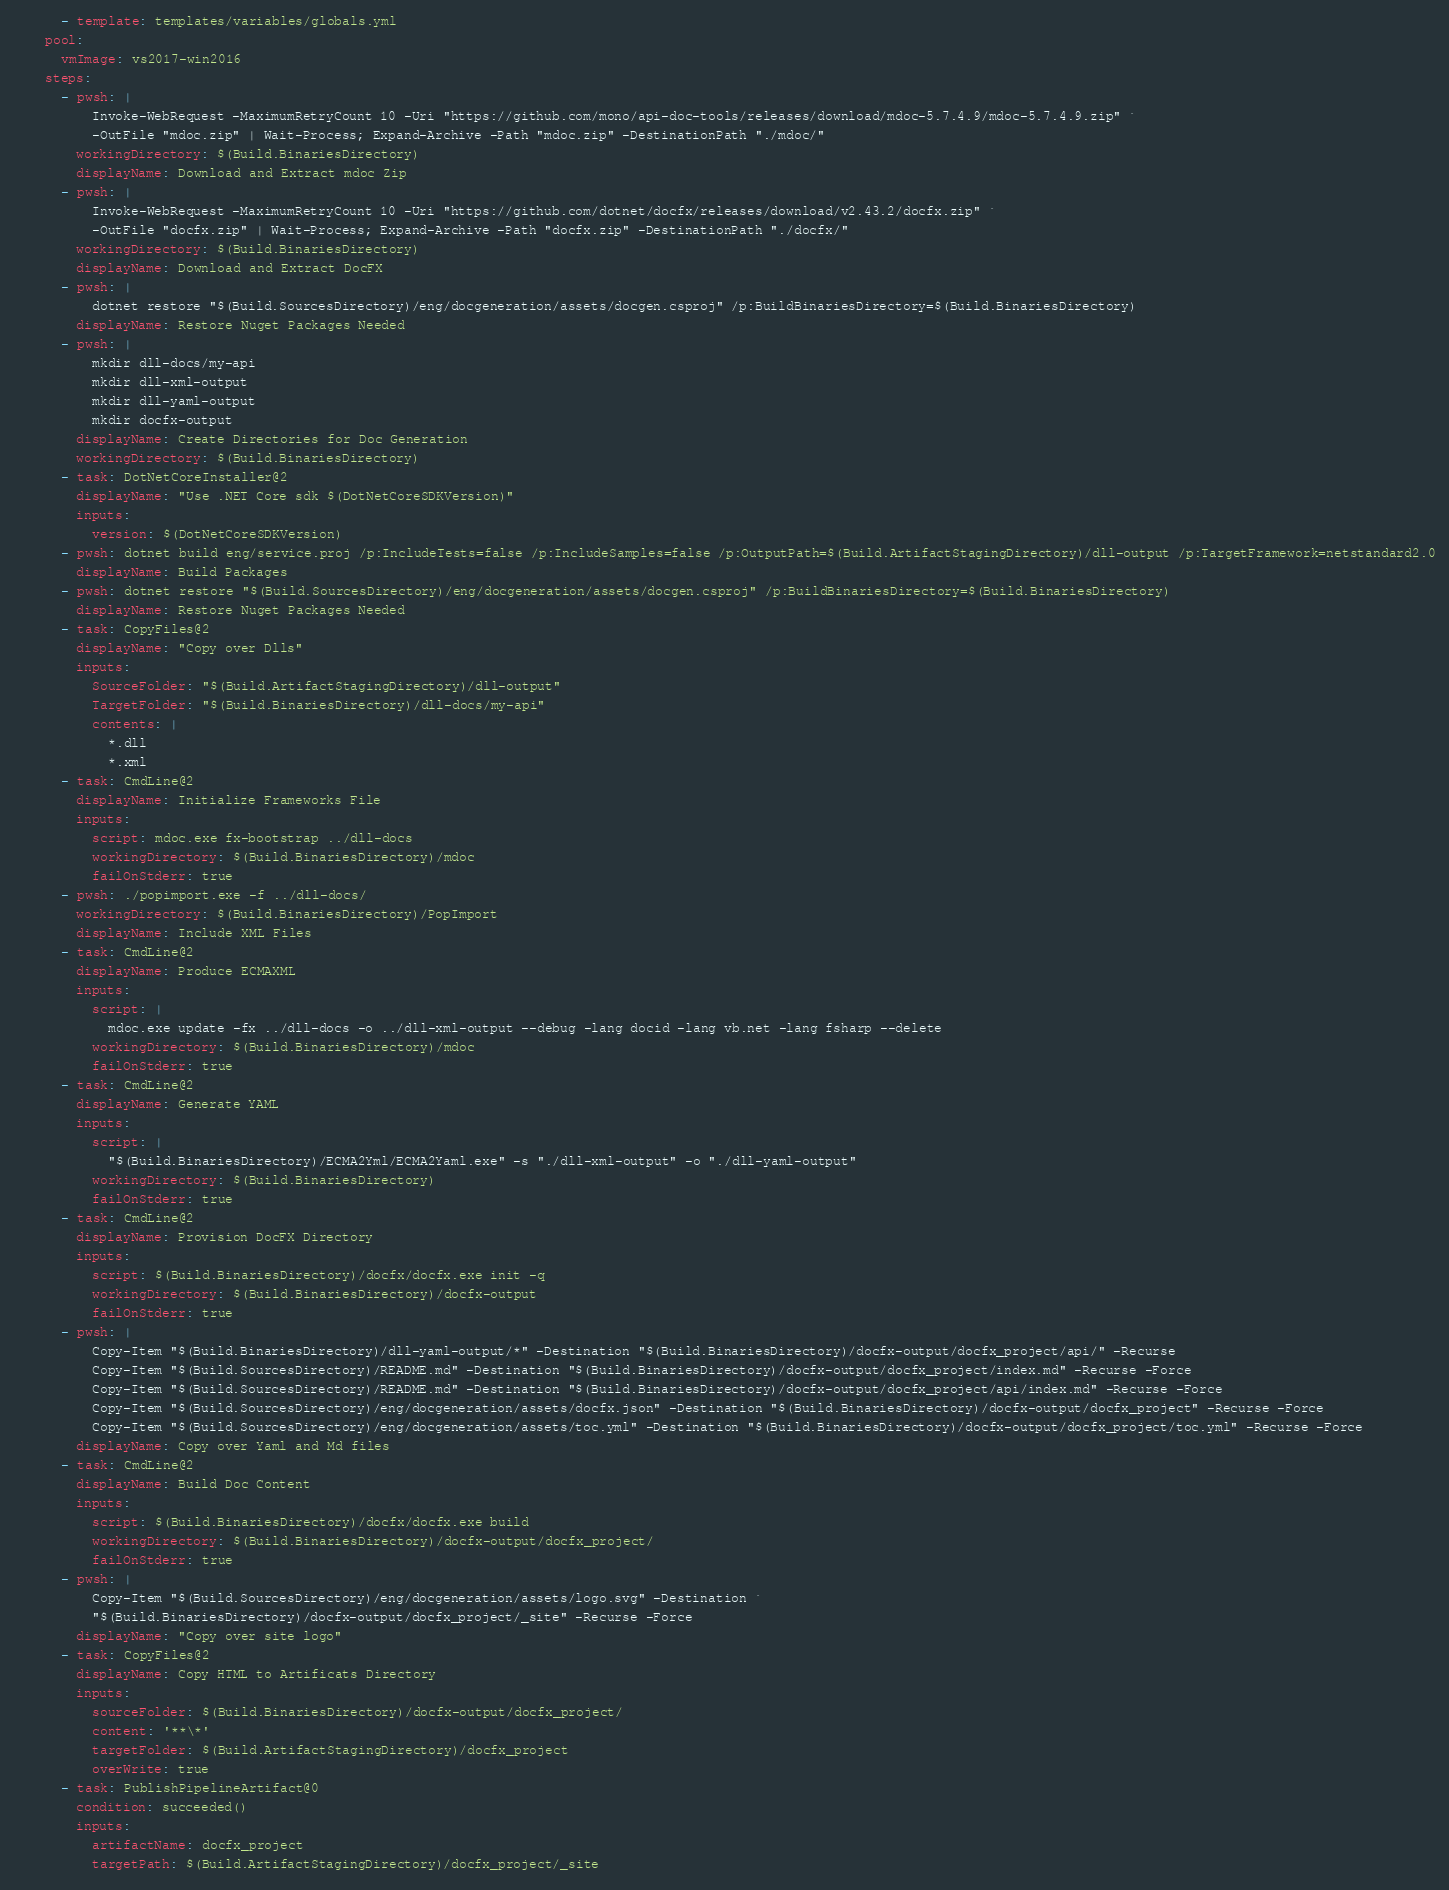<code> <loc_0><loc_0><loc_500><loc_500><_YAML_>      - template: templates/variables/globals.yml
    pool:
      vmImage: vs2017-win2016
    steps:
      - pwsh: |
          Invoke-WebRequest -MaximumRetryCount 10 -Uri "https://github.com/mono/api-doc-tools/releases/download/mdoc-5.7.4.9/mdoc-5.7.4.9.zip" `
          -OutFile "mdoc.zip" | Wait-Process; Expand-Archive -Path "mdoc.zip" -DestinationPath "./mdoc/"
        workingDirectory: $(Build.BinariesDirectory)
        displayName: Download and Extract mdoc Zip
      - pwsh: |
          Invoke-WebRequest -MaximumRetryCount 10 -Uri "https://github.com/dotnet/docfx/releases/download/v2.43.2/docfx.zip" `
          -OutFile "docfx.zip" | Wait-Process; Expand-Archive -Path "docfx.zip" -DestinationPath "./docfx/"
        workingDirectory: $(Build.BinariesDirectory)
        displayName: Download and Extract DocFX
      - pwsh: |
          dotnet restore "$(Build.SourcesDirectory)/eng/docgeneration/assets/docgen.csproj" /p:BuildBinariesDirectory=$(Build.BinariesDirectory)
        displayName: Restore Nuget Packages Needed
      - pwsh: |
          mkdir dll-docs/my-api
          mkdir dll-xml-output
          mkdir dll-yaml-output
          mkdir docfx-output
        displayName: Create Directories for Doc Generation
        workingDirectory: $(Build.BinariesDirectory)
      - task: DotNetCoreInstaller@2
        displayName: "Use .NET Core sdk $(DotNetCoreSDKVersion)"
        inputs:
          version: $(DotNetCoreSDKVersion)
      - pwsh: dotnet build eng/service.proj /p:IncludeTests=false /p:IncludeSamples=false /p:OutputPath=$(Build.ArtifactStagingDirectory)/dll-output /p:TargetFramework=netstandard2.0
        displayName: Build Packages
      - pwsh: dotnet restore "$(Build.SourcesDirectory)/eng/docgeneration/assets/docgen.csproj" /p:BuildBinariesDirectory=$(Build.BinariesDirectory)
        displayName: Restore Nuget Packages Needed
      - task: CopyFiles@2
        displayName: "Copy over Dlls"
        inputs:
          SourceFolder: "$(Build.ArtifactStagingDirectory)/dll-output"
          TargetFolder: "$(Build.BinariesDirectory)/dll-docs/my-api"
          contents: |
            *.dll
            *.xml
      - task: CmdLine@2
        displayName: Initialize Frameworks File
        inputs:
          script: mdoc.exe fx-bootstrap ../dll-docs
          workingDirectory: $(Build.BinariesDirectory)/mdoc
          failOnStderr: true
      - pwsh: ./popimport.exe -f ../dll-docs/
        workingDirectory: $(Build.BinariesDirectory)/PopImport
        displayName: Include XML Files
      - task: CmdLine@2
        displayName: Produce ECMAXML
        inputs:
          script: |
            mdoc.exe update -fx ../dll-docs -o ../dll-xml-output --debug -lang docid -lang vb.net -lang fsharp --delete
          workingDirectory: $(Build.BinariesDirectory)/mdoc
          failOnStderr: true
      - task: CmdLine@2
        displayName: Generate YAML
        inputs:
          script: |
            "$(Build.BinariesDirectory)/ECMA2Yml/ECMA2Yaml.exe" -s "./dll-xml-output" -o "./dll-yaml-output"
          workingDirectory: $(Build.BinariesDirectory)
          failOnStderr: true
      - task: CmdLine@2
        displayName: Provision DocFX Directory
        inputs:
          script: $(Build.BinariesDirectory)/docfx/docfx.exe init -q
          workingDirectory: $(Build.BinariesDirectory)/docfx-output
          failOnStderr: true
      - pwsh: |
          Copy-Item "$(Build.BinariesDirectory)/dll-yaml-output/*" -Destination "$(Build.BinariesDirectory)/docfx-output/docfx_project/api/" -Recurse
          Copy-Item "$(Build.SourcesDirectory)/README.md" -Destination "$(Build.BinariesDirectory)/docfx-output/docfx_project/index.md" -Recurse -Force
          Copy-Item "$(Build.SourcesDirectory)/README.md" -Destination "$(Build.BinariesDirectory)/docfx-output/docfx_project/api/index.md" -Recurse -Force
          Copy-Item "$(Build.SourcesDirectory)/eng/docgeneration/assets/docfx.json" -Destination "$(Build.BinariesDirectory)/docfx-output/docfx_project" -Recurse -Force
          Copy-Item "$(Build.SourcesDirectory)/eng/docgeneration/assets/toc.yml" -Destination "$(Build.BinariesDirectory)/docfx-output/docfx_project/toc.yml" -Recurse -Force
        displayName: Copy over Yaml and Md files
      - task: CmdLine@2
        displayName: Build Doc Content
        inputs:
          script: $(Build.BinariesDirectory)/docfx/docfx.exe build
          workingDirectory: $(Build.BinariesDirectory)/docfx-output/docfx_project/
          failOnStderr: true
      - pwsh: |
          Copy-Item "$(Build.SourcesDirectory)/eng/docgeneration/assets/logo.svg" -Destination `
          "$(Build.BinariesDirectory)/docfx-output/docfx_project/_site" -Recurse -Force
        displayName: "Copy over site logo"
      - task: CopyFiles@2
        displayName: Copy HTML to Artificats Directory
        inputs:
          sourceFolder: $(Build.BinariesDirectory)/docfx-output/docfx_project/
          content: '**\*'
          targetFolder: $(Build.ArtifactStagingDirectory)/docfx_project
          overWrite: true
      - task: PublishPipelineArtifact@0
        condition: succeeded()
        inputs:
          artifactName: docfx_project
          targetPath: $(Build.ArtifactStagingDirectory)/docfx_project/_site
</code> 